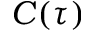<formula> <loc_0><loc_0><loc_500><loc_500>C ( \tau )</formula> 